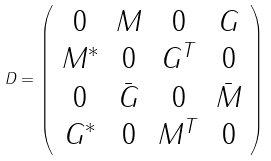<formula> <loc_0><loc_0><loc_500><loc_500>D = \left ( \begin{array} { c c c c } 0 & M & 0 & G \\ M ^ { * } & 0 & G ^ { T } & 0 \\ 0 & \bar { G } & 0 & \bar { M } \\ G ^ { * } & 0 & M ^ { T } & 0 \end{array} \right )</formula> 